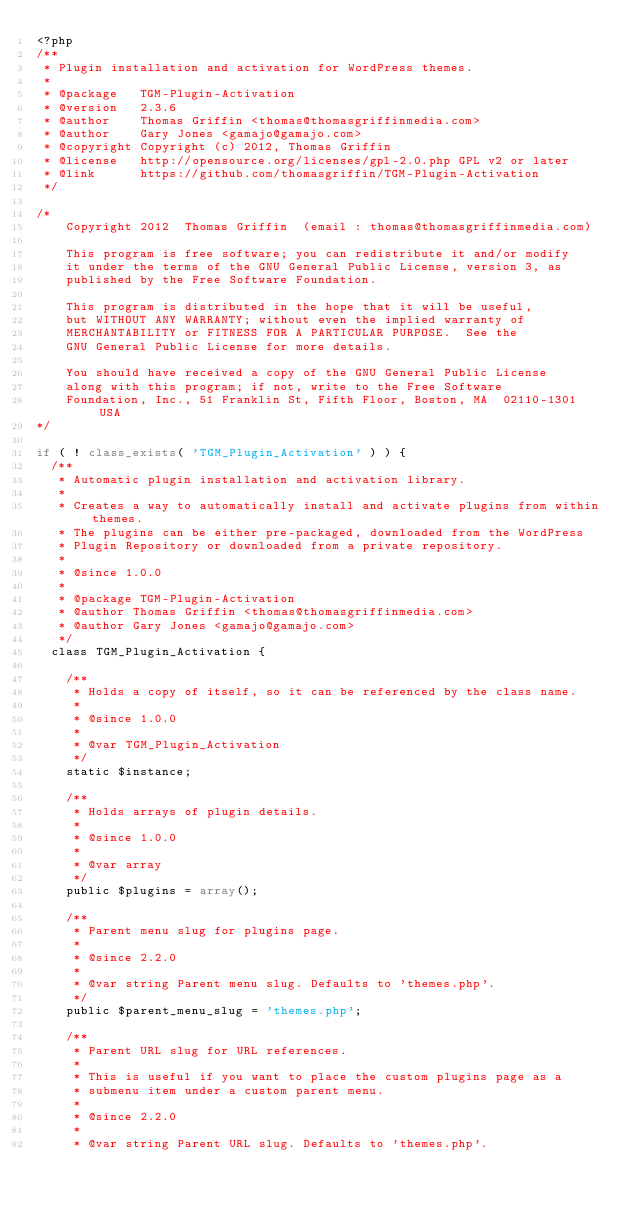<code> <loc_0><loc_0><loc_500><loc_500><_PHP_><?php
/**
 * Plugin installation and activation for WordPress themes.
 *
 * @package   TGM-Plugin-Activation
 * @version   2.3.6
 * @author    Thomas Griffin <thomas@thomasgriffinmedia.com>
 * @author    Gary Jones <gamajo@gamajo.com>
 * @copyright Copyright (c) 2012, Thomas Griffin
 * @license   http://opensource.org/licenses/gpl-2.0.php GPL v2 or later
 * @link      https://github.com/thomasgriffin/TGM-Plugin-Activation
 */

/*
    Copyright 2012  Thomas Griffin  (email : thomas@thomasgriffinmedia.com)

    This program is free software; you can redistribute it and/or modify
    it under the terms of the GNU General Public License, version 3, as
    published by the Free Software Foundation.

    This program is distributed in the hope that it will be useful,
    but WITHOUT ANY WARRANTY; without even the implied warranty of
    MERCHANTABILITY or FITNESS FOR A PARTICULAR PURPOSE.  See the
    GNU General Public License for more details.

    You should have received a copy of the GNU General Public License
    along with this program; if not, write to the Free Software
    Foundation, Inc., 51 Franklin St, Fifth Floor, Boston, MA  02110-1301  USA
*/

if ( ! class_exists( 'TGM_Plugin_Activation' ) ) {
	/**
 	 * Automatic plugin installation and activation library.
 	 *
 	 * Creates a way to automatically install and activate plugins from within themes.
 	 * The plugins can be either pre-packaged, downloaded from the WordPress
 	 * Plugin Repository or downloaded from a private repository.
 	 *
 	 * @since 1.0.0
 	 *
 	 * @package TGM-Plugin-Activation
 	 * @author Thomas Griffin <thomas@thomasgriffinmedia.com>
 	 * @author Gary Jones <gamajo@gamajo.com>
 	 */
	class TGM_Plugin_Activation {

		/**
	 	 * Holds a copy of itself, so it can be referenced by the class name.
	 	 *
	 	 * @since 1.0.0
	 	 *
	 	 * @var TGM_Plugin_Activation
	 	 */
		static $instance;

		/**
	 	 * Holds arrays of plugin details.
	 	 *
	 	 * @since 1.0.0
	 	 *
	 	 * @var array
	 	 */
		public $plugins = array();

		/**
	 	 * Parent menu slug for plugins page.
	 	 *
	 	 * @since 2.2.0
	 	 *
	 	 * @var string Parent menu slug. Defaults to 'themes.php'.
	 	 */
		public $parent_menu_slug = 'themes.php';

		/**
	 	 * Parent URL slug for URL references.
	 	 *
	 	 * This is useful if you want to place the custom plugins page as a
	 	 * submenu item under a custom parent menu.
	 	 *
	 	 * @since 2.2.0
	 	 *
	 	 * @var string Parent URL slug. Defaults to 'themes.php'.</code> 